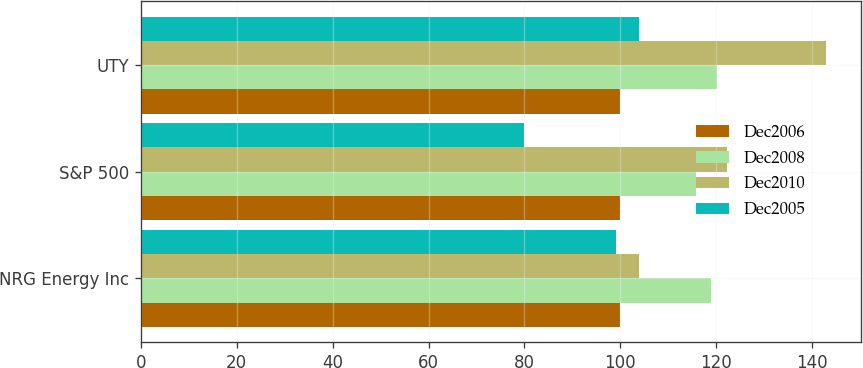Convert chart to OTSL. <chart><loc_0><loc_0><loc_500><loc_500><stacked_bar_chart><ecel><fcel>NRG Energy Inc<fcel>S&P 500<fcel>UTY<nl><fcel>Dec2006<fcel>100<fcel>100<fcel>100<nl><fcel>Dec2008<fcel>118.87<fcel>115.79<fcel>120.19<nl><fcel>Dec2010<fcel>103.98<fcel>122.16<fcel>142.99<nl><fcel>Dec2005<fcel>99.02<fcel>79.96<fcel>103.98<nl></chart> 